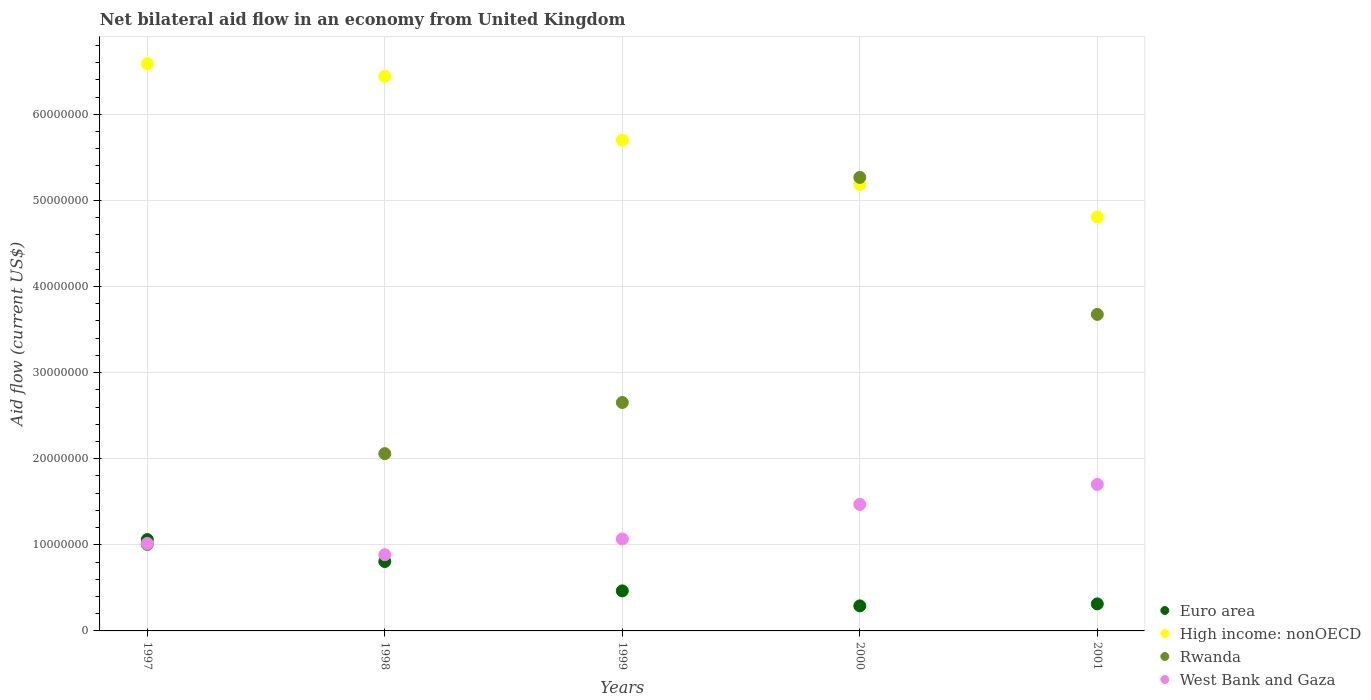Is the number of dotlines equal to the number of legend labels?
Your response must be concise. Yes. What is the net bilateral aid flow in Rwanda in 1999?
Provide a short and direct response. 2.65e+07. Across all years, what is the maximum net bilateral aid flow in Rwanda?
Your response must be concise. 5.27e+07. Across all years, what is the minimum net bilateral aid flow in Rwanda?
Your answer should be very brief. 1.00e+07. In which year was the net bilateral aid flow in High income: nonOECD maximum?
Offer a terse response. 1997. In which year was the net bilateral aid flow in High income: nonOECD minimum?
Your answer should be compact. 2001. What is the total net bilateral aid flow in High income: nonOECD in the graph?
Make the answer very short. 2.87e+08. What is the difference between the net bilateral aid flow in High income: nonOECD in 1998 and that in 2000?
Provide a succinct answer. 1.26e+07. What is the difference between the net bilateral aid flow in High income: nonOECD in 1998 and the net bilateral aid flow in Rwanda in 1999?
Offer a terse response. 3.79e+07. What is the average net bilateral aid flow in High income: nonOECD per year?
Provide a short and direct response. 5.74e+07. In the year 1998, what is the difference between the net bilateral aid flow in West Bank and Gaza and net bilateral aid flow in Euro area?
Make the answer very short. 7.90e+05. What is the ratio of the net bilateral aid flow in High income: nonOECD in 1999 to that in 2001?
Offer a terse response. 1.19. What is the difference between the highest and the second highest net bilateral aid flow in Rwanda?
Ensure brevity in your answer.  1.59e+07. What is the difference between the highest and the lowest net bilateral aid flow in Euro area?
Your answer should be very brief. 7.70e+06. In how many years, is the net bilateral aid flow in Rwanda greater than the average net bilateral aid flow in Rwanda taken over all years?
Your answer should be very brief. 2. Is it the case that in every year, the sum of the net bilateral aid flow in West Bank and Gaza and net bilateral aid flow in Rwanda  is greater than the net bilateral aid flow in Euro area?
Provide a short and direct response. Yes. Does the net bilateral aid flow in West Bank and Gaza monotonically increase over the years?
Your answer should be very brief. No. How many years are there in the graph?
Offer a terse response. 5. Where does the legend appear in the graph?
Your answer should be compact. Bottom right. What is the title of the graph?
Offer a very short reply. Net bilateral aid flow in an economy from United Kingdom. What is the Aid flow (current US$) in Euro area in 1997?
Give a very brief answer. 1.06e+07. What is the Aid flow (current US$) of High income: nonOECD in 1997?
Make the answer very short. 6.59e+07. What is the Aid flow (current US$) in Rwanda in 1997?
Provide a succinct answer. 1.00e+07. What is the Aid flow (current US$) in West Bank and Gaza in 1997?
Give a very brief answer. 1.02e+07. What is the Aid flow (current US$) of Euro area in 1998?
Keep it short and to the point. 8.06e+06. What is the Aid flow (current US$) of High income: nonOECD in 1998?
Keep it short and to the point. 6.44e+07. What is the Aid flow (current US$) in Rwanda in 1998?
Keep it short and to the point. 2.06e+07. What is the Aid flow (current US$) of West Bank and Gaza in 1998?
Your answer should be compact. 8.85e+06. What is the Aid flow (current US$) in Euro area in 1999?
Offer a terse response. 4.65e+06. What is the Aid flow (current US$) of High income: nonOECD in 1999?
Ensure brevity in your answer.  5.70e+07. What is the Aid flow (current US$) of Rwanda in 1999?
Offer a terse response. 2.65e+07. What is the Aid flow (current US$) of West Bank and Gaza in 1999?
Offer a very short reply. 1.07e+07. What is the Aid flow (current US$) of Euro area in 2000?
Provide a succinct answer. 2.91e+06. What is the Aid flow (current US$) in High income: nonOECD in 2000?
Make the answer very short. 5.18e+07. What is the Aid flow (current US$) in Rwanda in 2000?
Offer a terse response. 5.27e+07. What is the Aid flow (current US$) of West Bank and Gaza in 2000?
Your response must be concise. 1.47e+07. What is the Aid flow (current US$) of Euro area in 2001?
Ensure brevity in your answer.  3.14e+06. What is the Aid flow (current US$) in High income: nonOECD in 2001?
Your answer should be compact. 4.81e+07. What is the Aid flow (current US$) in Rwanda in 2001?
Keep it short and to the point. 3.68e+07. What is the Aid flow (current US$) of West Bank and Gaza in 2001?
Provide a succinct answer. 1.70e+07. Across all years, what is the maximum Aid flow (current US$) of Euro area?
Keep it short and to the point. 1.06e+07. Across all years, what is the maximum Aid flow (current US$) of High income: nonOECD?
Keep it short and to the point. 6.59e+07. Across all years, what is the maximum Aid flow (current US$) in Rwanda?
Provide a short and direct response. 5.27e+07. Across all years, what is the maximum Aid flow (current US$) of West Bank and Gaza?
Offer a terse response. 1.70e+07. Across all years, what is the minimum Aid flow (current US$) in Euro area?
Offer a terse response. 2.91e+06. Across all years, what is the minimum Aid flow (current US$) in High income: nonOECD?
Give a very brief answer. 4.81e+07. Across all years, what is the minimum Aid flow (current US$) in Rwanda?
Your answer should be very brief. 1.00e+07. Across all years, what is the minimum Aid flow (current US$) of West Bank and Gaza?
Ensure brevity in your answer.  8.85e+06. What is the total Aid flow (current US$) in Euro area in the graph?
Provide a short and direct response. 2.94e+07. What is the total Aid flow (current US$) in High income: nonOECD in the graph?
Offer a very short reply. 2.87e+08. What is the total Aid flow (current US$) in Rwanda in the graph?
Make the answer very short. 1.47e+08. What is the total Aid flow (current US$) of West Bank and Gaza in the graph?
Your answer should be compact. 6.14e+07. What is the difference between the Aid flow (current US$) in Euro area in 1997 and that in 1998?
Provide a short and direct response. 2.55e+06. What is the difference between the Aid flow (current US$) in High income: nonOECD in 1997 and that in 1998?
Make the answer very short. 1.47e+06. What is the difference between the Aid flow (current US$) in Rwanda in 1997 and that in 1998?
Keep it short and to the point. -1.06e+07. What is the difference between the Aid flow (current US$) of West Bank and Gaza in 1997 and that in 1998?
Give a very brief answer. 1.31e+06. What is the difference between the Aid flow (current US$) of Euro area in 1997 and that in 1999?
Make the answer very short. 5.96e+06. What is the difference between the Aid flow (current US$) in High income: nonOECD in 1997 and that in 1999?
Offer a very short reply. 8.89e+06. What is the difference between the Aid flow (current US$) of Rwanda in 1997 and that in 1999?
Provide a short and direct response. -1.65e+07. What is the difference between the Aid flow (current US$) in West Bank and Gaza in 1997 and that in 1999?
Your answer should be very brief. -5.20e+05. What is the difference between the Aid flow (current US$) in Euro area in 1997 and that in 2000?
Keep it short and to the point. 7.70e+06. What is the difference between the Aid flow (current US$) in High income: nonOECD in 1997 and that in 2000?
Your answer should be compact. 1.40e+07. What is the difference between the Aid flow (current US$) of Rwanda in 1997 and that in 2000?
Your answer should be very brief. -4.26e+07. What is the difference between the Aid flow (current US$) of West Bank and Gaza in 1997 and that in 2000?
Offer a very short reply. -4.53e+06. What is the difference between the Aid flow (current US$) in Euro area in 1997 and that in 2001?
Give a very brief answer. 7.47e+06. What is the difference between the Aid flow (current US$) of High income: nonOECD in 1997 and that in 2001?
Provide a succinct answer. 1.78e+07. What is the difference between the Aid flow (current US$) in Rwanda in 1997 and that in 2001?
Offer a terse response. -2.67e+07. What is the difference between the Aid flow (current US$) of West Bank and Gaza in 1997 and that in 2001?
Provide a succinct answer. -6.85e+06. What is the difference between the Aid flow (current US$) in Euro area in 1998 and that in 1999?
Give a very brief answer. 3.41e+06. What is the difference between the Aid flow (current US$) of High income: nonOECD in 1998 and that in 1999?
Your answer should be compact. 7.42e+06. What is the difference between the Aid flow (current US$) of Rwanda in 1998 and that in 1999?
Offer a terse response. -5.94e+06. What is the difference between the Aid flow (current US$) of West Bank and Gaza in 1998 and that in 1999?
Offer a terse response. -1.83e+06. What is the difference between the Aid flow (current US$) of Euro area in 1998 and that in 2000?
Offer a terse response. 5.15e+06. What is the difference between the Aid flow (current US$) of High income: nonOECD in 1998 and that in 2000?
Your answer should be compact. 1.26e+07. What is the difference between the Aid flow (current US$) in Rwanda in 1998 and that in 2000?
Ensure brevity in your answer.  -3.21e+07. What is the difference between the Aid flow (current US$) in West Bank and Gaza in 1998 and that in 2000?
Offer a terse response. -5.84e+06. What is the difference between the Aid flow (current US$) of Euro area in 1998 and that in 2001?
Make the answer very short. 4.92e+06. What is the difference between the Aid flow (current US$) of High income: nonOECD in 1998 and that in 2001?
Your answer should be very brief. 1.63e+07. What is the difference between the Aid flow (current US$) of Rwanda in 1998 and that in 2001?
Offer a terse response. -1.62e+07. What is the difference between the Aid flow (current US$) in West Bank and Gaza in 1998 and that in 2001?
Provide a succinct answer. -8.16e+06. What is the difference between the Aid flow (current US$) of Euro area in 1999 and that in 2000?
Offer a very short reply. 1.74e+06. What is the difference between the Aid flow (current US$) of High income: nonOECD in 1999 and that in 2000?
Your answer should be very brief. 5.15e+06. What is the difference between the Aid flow (current US$) in Rwanda in 1999 and that in 2000?
Offer a terse response. -2.61e+07. What is the difference between the Aid flow (current US$) in West Bank and Gaza in 1999 and that in 2000?
Give a very brief answer. -4.01e+06. What is the difference between the Aid flow (current US$) of Euro area in 1999 and that in 2001?
Make the answer very short. 1.51e+06. What is the difference between the Aid flow (current US$) in High income: nonOECD in 1999 and that in 2001?
Ensure brevity in your answer.  8.92e+06. What is the difference between the Aid flow (current US$) of Rwanda in 1999 and that in 2001?
Make the answer very short. -1.02e+07. What is the difference between the Aid flow (current US$) of West Bank and Gaza in 1999 and that in 2001?
Provide a succinct answer. -6.33e+06. What is the difference between the Aid flow (current US$) in Euro area in 2000 and that in 2001?
Provide a short and direct response. -2.30e+05. What is the difference between the Aid flow (current US$) of High income: nonOECD in 2000 and that in 2001?
Your response must be concise. 3.77e+06. What is the difference between the Aid flow (current US$) of Rwanda in 2000 and that in 2001?
Keep it short and to the point. 1.59e+07. What is the difference between the Aid flow (current US$) of West Bank and Gaza in 2000 and that in 2001?
Your answer should be compact. -2.32e+06. What is the difference between the Aid flow (current US$) in Euro area in 1997 and the Aid flow (current US$) in High income: nonOECD in 1998?
Keep it short and to the point. -5.38e+07. What is the difference between the Aid flow (current US$) in Euro area in 1997 and the Aid flow (current US$) in Rwanda in 1998?
Give a very brief answer. -9.98e+06. What is the difference between the Aid flow (current US$) of Euro area in 1997 and the Aid flow (current US$) of West Bank and Gaza in 1998?
Give a very brief answer. 1.76e+06. What is the difference between the Aid flow (current US$) of High income: nonOECD in 1997 and the Aid flow (current US$) of Rwanda in 1998?
Your response must be concise. 4.53e+07. What is the difference between the Aid flow (current US$) of High income: nonOECD in 1997 and the Aid flow (current US$) of West Bank and Gaza in 1998?
Provide a short and direct response. 5.70e+07. What is the difference between the Aid flow (current US$) of Rwanda in 1997 and the Aid flow (current US$) of West Bank and Gaza in 1998?
Ensure brevity in your answer.  1.19e+06. What is the difference between the Aid flow (current US$) of Euro area in 1997 and the Aid flow (current US$) of High income: nonOECD in 1999?
Your answer should be very brief. -4.64e+07. What is the difference between the Aid flow (current US$) in Euro area in 1997 and the Aid flow (current US$) in Rwanda in 1999?
Make the answer very short. -1.59e+07. What is the difference between the Aid flow (current US$) of Euro area in 1997 and the Aid flow (current US$) of West Bank and Gaza in 1999?
Provide a succinct answer. -7.00e+04. What is the difference between the Aid flow (current US$) of High income: nonOECD in 1997 and the Aid flow (current US$) of Rwanda in 1999?
Offer a terse response. 3.94e+07. What is the difference between the Aid flow (current US$) in High income: nonOECD in 1997 and the Aid flow (current US$) in West Bank and Gaza in 1999?
Your answer should be compact. 5.52e+07. What is the difference between the Aid flow (current US$) in Rwanda in 1997 and the Aid flow (current US$) in West Bank and Gaza in 1999?
Offer a terse response. -6.40e+05. What is the difference between the Aid flow (current US$) of Euro area in 1997 and the Aid flow (current US$) of High income: nonOECD in 2000?
Your response must be concise. -4.12e+07. What is the difference between the Aid flow (current US$) in Euro area in 1997 and the Aid flow (current US$) in Rwanda in 2000?
Offer a terse response. -4.21e+07. What is the difference between the Aid flow (current US$) of Euro area in 1997 and the Aid flow (current US$) of West Bank and Gaza in 2000?
Make the answer very short. -4.08e+06. What is the difference between the Aid flow (current US$) of High income: nonOECD in 1997 and the Aid flow (current US$) of Rwanda in 2000?
Ensure brevity in your answer.  1.32e+07. What is the difference between the Aid flow (current US$) in High income: nonOECD in 1997 and the Aid flow (current US$) in West Bank and Gaza in 2000?
Make the answer very short. 5.12e+07. What is the difference between the Aid flow (current US$) of Rwanda in 1997 and the Aid flow (current US$) of West Bank and Gaza in 2000?
Your response must be concise. -4.65e+06. What is the difference between the Aid flow (current US$) in Euro area in 1997 and the Aid flow (current US$) in High income: nonOECD in 2001?
Your answer should be compact. -3.75e+07. What is the difference between the Aid flow (current US$) of Euro area in 1997 and the Aid flow (current US$) of Rwanda in 2001?
Keep it short and to the point. -2.62e+07. What is the difference between the Aid flow (current US$) of Euro area in 1997 and the Aid flow (current US$) of West Bank and Gaza in 2001?
Your answer should be compact. -6.40e+06. What is the difference between the Aid flow (current US$) in High income: nonOECD in 1997 and the Aid flow (current US$) in Rwanda in 2001?
Provide a short and direct response. 2.91e+07. What is the difference between the Aid flow (current US$) in High income: nonOECD in 1997 and the Aid flow (current US$) in West Bank and Gaza in 2001?
Provide a succinct answer. 4.89e+07. What is the difference between the Aid flow (current US$) of Rwanda in 1997 and the Aid flow (current US$) of West Bank and Gaza in 2001?
Keep it short and to the point. -6.97e+06. What is the difference between the Aid flow (current US$) of Euro area in 1998 and the Aid flow (current US$) of High income: nonOECD in 1999?
Ensure brevity in your answer.  -4.89e+07. What is the difference between the Aid flow (current US$) in Euro area in 1998 and the Aid flow (current US$) in Rwanda in 1999?
Keep it short and to the point. -1.85e+07. What is the difference between the Aid flow (current US$) of Euro area in 1998 and the Aid flow (current US$) of West Bank and Gaza in 1999?
Offer a terse response. -2.62e+06. What is the difference between the Aid flow (current US$) in High income: nonOECD in 1998 and the Aid flow (current US$) in Rwanda in 1999?
Offer a terse response. 3.79e+07. What is the difference between the Aid flow (current US$) of High income: nonOECD in 1998 and the Aid flow (current US$) of West Bank and Gaza in 1999?
Provide a succinct answer. 5.37e+07. What is the difference between the Aid flow (current US$) in Rwanda in 1998 and the Aid flow (current US$) in West Bank and Gaza in 1999?
Keep it short and to the point. 9.91e+06. What is the difference between the Aid flow (current US$) of Euro area in 1998 and the Aid flow (current US$) of High income: nonOECD in 2000?
Provide a short and direct response. -4.38e+07. What is the difference between the Aid flow (current US$) in Euro area in 1998 and the Aid flow (current US$) in Rwanda in 2000?
Ensure brevity in your answer.  -4.46e+07. What is the difference between the Aid flow (current US$) in Euro area in 1998 and the Aid flow (current US$) in West Bank and Gaza in 2000?
Give a very brief answer. -6.63e+06. What is the difference between the Aid flow (current US$) of High income: nonOECD in 1998 and the Aid flow (current US$) of Rwanda in 2000?
Provide a succinct answer. 1.17e+07. What is the difference between the Aid flow (current US$) of High income: nonOECD in 1998 and the Aid flow (current US$) of West Bank and Gaza in 2000?
Give a very brief answer. 4.97e+07. What is the difference between the Aid flow (current US$) in Rwanda in 1998 and the Aid flow (current US$) in West Bank and Gaza in 2000?
Offer a very short reply. 5.90e+06. What is the difference between the Aid flow (current US$) in Euro area in 1998 and the Aid flow (current US$) in High income: nonOECD in 2001?
Your response must be concise. -4.00e+07. What is the difference between the Aid flow (current US$) of Euro area in 1998 and the Aid flow (current US$) of Rwanda in 2001?
Your answer should be compact. -2.87e+07. What is the difference between the Aid flow (current US$) in Euro area in 1998 and the Aid flow (current US$) in West Bank and Gaza in 2001?
Your response must be concise. -8.95e+06. What is the difference between the Aid flow (current US$) in High income: nonOECD in 1998 and the Aid flow (current US$) in Rwanda in 2001?
Provide a short and direct response. 2.76e+07. What is the difference between the Aid flow (current US$) of High income: nonOECD in 1998 and the Aid flow (current US$) of West Bank and Gaza in 2001?
Provide a short and direct response. 4.74e+07. What is the difference between the Aid flow (current US$) in Rwanda in 1998 and the Aid flow (current US$) in West Bank and Gaza in 2001?
Give a very brief answer. 3.58e+06. What is the difference between the Aid flow (current US$) of Euro area in 1999 and the Aid flow (current US$) of High income: nonOECD in 2000?
Your response must be concise. -4.72e+07. What is the difference between the Aid flow (current US$) of Euro area in 1999 and the Aid flow (current US$) of Rwanda in 2000?
Your answer should be compact. -4.80e+07. What is the difference between the Aid flow (current US$) in Euro area in 1999 and the Aid flow (current US$) in West Bank and Gaza in 2000?
Offer a terse response. -1.00e+07. What is the difference between the Aid flow (current US$) in High income: nonOECD in 1999 and the Aid flow (current US$) in Rwanda in 2000?
Keep it short and to the point. 4.32e+06. What is the difference between the Aid flow (current US$) of High income: nonOECD in 1999 and the Aid flow (current US$) of West Bank and Gaza in 2000?
Provide a succinct answer. 4.23e+07. What is the difference between the Aid flow (current US$) in Rwanda in 1999 and the Aid flow (current US$) in West Bank and Gaza in 2000?
Make the answer very short. 1.18e+07. What is the difference between the Aid flow (current US$) of Euro area in 1999 and the Aid flow (current US$) of High income: nonOECD in 2001?
Keep it short and to the point. -4.34e+07. What is the difference between the Aid flow (current US$) of Euro area in 1999 and the Aid flow (current US$) of Rwanda in 2001?
Your answer should be compact. -3.21e+07. What is the difference between the Aid flow (current US$) in Euro area in 1999 and the Aid flow (current US$) in West Bank and Gaza in 2001?
Provide a short and direct response. -1.24e+07. What is the difference between the Aid flow (current US$) of High income: nonOECD in 1999 and the Aid flow (current US$) of Rwanda in 2001?
Provide a succinct answer. 2.02e+07. What is the difference between the Aid flow (current US$) in High income: nonOECD in 1999 and the Aid flow (current US$) in West Bank and Gaza in 2001?
Your answer should be compact. 4.00e+07. What is the difference between the Aid flow (current US$) of Rwanda in 1999 and the Aid flow (current US$) of West Bank and Gaza in 2001?
Make the answer very short. 9.52e+06. What is the difference between the Aid flow (current US$) in Euro area in 2000 and the Aid flow (current US$) in High income: nonOECD in 2001?
Give a very brief answer. -4.52e+07. What is the difference between the Aid flow (current US$) in Euro area in 2000 and the Aid flow (current US$) in Rwanda in 2001?
Provide a short and direct response. -3.38e+07. What is the difference between the Aid flow (current US$) of Euro area in 2000 and the Aid flow (current US$) of West Bank and Gaza in 2001?
Your response must be concise. -1.41e+07. What is the difference between the Aid flow (current US$) in High income: nonOECD in 2000 and the Aid flow (current US$) in Rwanda in 2001?
Give a very brief answer. 1.51e+07. What is the difference between the Aid flow (current US$) of High income: nonOECD in 2000 and the Aid flow (current US$) of West Bank and Gaza in 2001?
Offer a terse response. 3.48e+07. What is the difference between the Aid flow (current US$) in Rwanda in 2000 and the Aid flow (current US$) in West Bank and Gaza in 2001?
Your answer should be very brief. 3.57e+07. What is the average Aid flow (current US$) of Euro area per year?
Ensure brevity in your answer.  5.87e+06. What is the average Aid flow (current US$) of High income: nonOECD per year?
Make the answer very short. 5.74e+07. What is the average Aid flow (current US$) of Rwanda per year?
Offer a very short reply. 2.93e+07. What is the average Aid flow (current US$) of West Bank and Gaza per year?
Offer a terse response. 1.23e+07. In the year 1997, what is the difference between the Aid flow (current US$) in Euro area and Aid flow (current US$) in High income: nonOECD?
Provide a short and direct response. -5.53e+07. In the year 1997, what is the difference between the Aid flow (current US$) in Euro area and Aid flow (current US$) in Rwanda?
Your response must be concise. 5.70e+05. In the year 1997, what is the difference between the Aid flow (current US$) in High income: nonOECD and Aid flow (current US$) in Rwanda?
Offer a terse response. 5.58e+07. In the year 1997, what is the difference between the Aid flow (current US$) in High income: nonOECD and Aid flow (current US$) in West Bank and Gaza?
Your answer should be very brief. 5.57e+07. In the year 1998, what is the difference between the Aid flow (current US$) of Euro area and Aid flow (current US$) of High income: nonOECD?
Keep it short and to the point. -5.64e+07. In the year 1998, what is the difference between the Aid flow (current US$) in Euro area and Aid flow (current US$) in Rwanda?
Ensure brevity in your answer.  -1.25e+07. In the year 1998, what is the difference between the Aid flow (current US$) in Euro area and Aid flow (current US$) in West Bank and Gaza?
Ensure brevity in your answer.  -7.90e+05. In the year 1998, what is the difference between the Aid flow (current US$) in High income: nonOECD and Aid flow (current US$) in Rwanda?
Provide a short and direct response. 4.38e+07. In the year 1998, what is the difference between the Aid flow (current US$) of High income: nonOECD and Aid flow (current US$) of West Bank and Gaza?
Keep it short and to the point. 5.56e+07. In the year 1998, what is the difference between the Aid flow (current US$) of Rwanda and Aid flow (current US$) of West Bank and Gaza?
Your answer should be very brief. 1.17e+07. In the year 1999, what is the difference between the Aid flow (current US$) in Euro area and Aid flow (current US$) in High income: nonOECD?
Give a very brief answer. -5.23e+07. In the year 1999, what is the difference between the Aid flow (current US$) in Euro area and Aid flow (current US$) in Rwanda?
Provide a short and direct response. -2.19e+07. In the year 1999, what is the difference between the Aid flow (current US$) of Euro area and Aid flow (current US$) of West Bank and Gaza?
Provide a succinct answer. -6.03e+06. In the year 1999, what is the difference between the Aid flow (current US$) in High income: nonOECD and Aid flow (current US$) in Rwanda?
Your answer should be compact. 3.05e+07. In the year 1999, what is the difference between the Aid flow (current US$) in High income: nonOECD and Aid flow (current US$) in West Bank and Gaza?
Offer a terse response. 4.63e+07. In the year 1999, what is the difference between the Aid flow (current US$) of Rwanda and Aid flow (current US$) of West Bank and Gaza?
Your answer should be very brief. 1.58e+07. In the year 2000, what is the difference between the Aid flow (current US$) in Euro area and Aid flow (current US$) in High income: nonOECD?
Keep it short and to the point. -4.89e+07. In the year 2000, what is the difference between the Aid flow (current US$) of Euro area and Aid flow (current US$) of Rwanda?
Make the answer very short. -4.98e+07. In the year 2000, what is the difference between the Aid flow (current US$) of Euro area and Aid flow (current US$) of West Bank and Gaza?
Your answer should be very brief. -1.18e+07. In the year 2000, what is the difference between the Aid flow (current US$) in High income: nonOECD and Aid flow (current US$) in Rwanda?
Provide a short and direct response. -8.30e+05. In the year 2000, what is the difference between the Aid flow (current US$) in High income: nonOECD and Aid flow (current US$) in West Bank and Gaza?
Keep it short and to the point. 3.72e+07. In the year 2000, what is the difference between the Aid flow (current US$) in Rwanda and Aid flow (current US$) in West Bank and Gaza?
Provide a short and direct response. 3.80e+07. In the year 2001, what is the difference between the Aid flow (current US$) of Euro area and Aid flow (current US$) of High income: nonOECD?
Your response must be concise. -4.49e+07. In the year 2001, what is the difference between the Aid flow (current US$) of Euro area and Aid flow (current US$) of Rwanda?
Ensure brevity in your answer.  -3.36e+07. In the year 2001, what is the difference between the Aid flow (current US$) of Euro area and Aid flow (current US$) of West Bank and Gaza?
Give a very brief answer. -1.39e+07. In the year 2001, what is the difference between the Aid flow (current US$) in High income: nonOECD and Aid flow (current US$) in Rwanda?
Offer a very short reply. 1.13e+07. In the year 2001, what is the difference between the Aid flow (current US$) of High income: nonOECD and Aid flow (current US$) of West Bank and Gaza?
Provide a succinct answer. 3.11e+07. In the year 2001, what is the difference between the Aid flow (current US$) in Rwanda and Aid flow (current US$) in West Bank and Gaza?
Provide a succinct answer. 1.98e+07. What is the ratio of the Aid flow (current US$) in Euro area in 1997 to that in 1998?
Keep it short and to the point. 1.32. What is the ratio of the Aid flow (current US$) in High income: nonOECD in 1997 to that in 1998?
Ensure brevity in your answer.  1.02. What is the ratio of the Aid flow (current US$) in Rwanda in 1997 to that in 1998?
Your response must be concise. 0.49. What is the ratio of the Aid flow (current US$) of West Bank and Gaza in 1997 to that in 1998?
Ensure brevity in your answer.  1.15. What is the ratio of the Aid flow (current US$) in Euro area in 1997 to that in 1999?
Provide a short and direct response. 2.28. What is the ratio of the Aid flow (current US$) in High income: nonOECD in 1997 to that in 1999?
Ensure brevity in your answer.  1.16. What is the ratio of the Aid flow (current US$) in Rwanda in 1997 to that in 1999?
Provide a short and direct response. 0.38. What is the ratio of the Aid flow (current US$) of West Bank and Gaza in 1997 to that in 1999?
Your answer should be compact. 0.95. What is the ratio of the Aid flow (current US$) in Euro area in 1997 to that in 2000?
Your answer should be compact. 3.65. What is the ratio of the Aid flow (current US$) in High income: nonOECD in 1997 to that in 2000?
Your answer should be very brief. 1.27. What is the ratio of the Aid flow (current US$) of Rwanda in 1997 to that in 2000?
Provide a short and direct response. 0.19. What is the ratio of the Aid flow (current US$) of West Bank and Gaza in 1997 to that in 2000?
Your answer should be compact. 0.69. What is the ratio of the Aid flow (current US$) of Euro area in 1997 to that in 2001?
Provide a succinct answer. 3.38. What is the ratio of the Aid flow (current US$) in High income: nonOECD in 1997 to that in 2001?
Make the answer very short. 1.37. What is the ratio of the Aid flow (current US$) in Rwanda in 1997 to that in 2001?
Offer a very short reply. 0.27. What is the ratio of the Aid flow (current US$) in West Bank and Gaza in 1997 to that in 2001?
Offer a very short reply. 0.6. What is the ratio of the Aid flow (current US$) of Euro area in 1998 to that in 1999?
Keep it short and to the point. 1.73. What is the ratio of the Aid flow (current US$) in High income: nonOECD in 1998 to that in 1999?
Offer a terse response. 1.13. What is the ratio of the Aid flow (current US$) of Rwanda in 1998 to that in 1999?
Your answer should be very brief. 0.78. What is the ratio of the Aid flow (current US$) of West Bank and Gaza in 1998 to that in 1999?
Your answer should be very brief. 0.83. What is the ratio of the Aid flow (current US$) of Euro area in 1998 to that in 2000?
Make the answer very short. 2.77. What is the ratio of the Aid flow (current US$) of High income: nonOECD in 1998 to that in 2000?
Your response must be concise. 1.24. What is the ratio of the Aid flow (current US$) in Rwanda in 1998 to that in 2000?
Your response must be concise. 0.39. What is the ratio of the Aid flow (current US$) in West Bank and Gaza in 1998 to that in 2000?
Your answer should be compact. 0.6. What is the ratio of the Aid flow (current US$) in Euro area in 1998 to that in 2001?
Ensure brevity in your answer.  2.57. What is the ratio of the Aid flow (current US$) of High income: nonOECD in 1998 to that in 2001?
Provide a succinct answer. 1.34. What is the ratio of the Aid flow (current US$) of Rwanda in 1998 to that in 2001?
Provide a succinct answer. 0.56. What is the ratio of the Aid flow (current US$) of West Bank and Gaza in 1998 to that in 2001?
Make the answer very short. 0.52. What is the ratio of the Aid flow (current US$) of Euro area in 1999 to that in 2000?
Give a very brief answer. 1.6. What is the ratio of the Aid flow (current US$) of High income: nonOECD in 1999 to that in 2000?
Provide a short and direct response. 1.1. What is the ratio of the Aid flow (current US$) in Rwanda in 1999 to that in 2000?
Your response must be concise. 0.5. What is the ratio of the Aid flow (current US$) of West Bank and Gaza in 1999 to that in 2000?
Your response must be concise. 0.73. What is the ratio of the Aid flow (current US$) of Euro area in 1999 to that in 2001?
Your answer should be compact. 1.48. What is the ratio of the Aid flow (current US$) of High income: nonOECD in 1999 to that in 2001?
Your answer should be very brief. 1.19. What is the ratio of the Aid flow (current US$) in Rwanda in 1999 to that in 2001?
Offer a very short reply. 0.72. What is the ratio of the Aid flow (current US$) in West Bank and Gaza in 1999 to that in 2001?
Ensure brevity in your answer.  0.63. What is the ratio of the Aid flow (current US$) in Euro area in 2000 to that in 2001?
Offer a very short reply. 0.93. What is the ratio of the Aid flow (current US$) in High income: nonOECD in 2000 to that in 2001?
Offer a very short reply. 1.08. What is the ratio of the Aid flow (current US$) in Rwanda in 2000 to that in 2001?
Offer a terse response. 1.43. What is the ratio of the Aid flow (current US$) in West Bank and Gaza in 2000 to that in 2001?
Your response must be concise. 0.86. What is the difference between the highest and the second highest Aid flow (current US$) of Euro area?
Your answer should be very brief. 2.55e+06. What is the difference between the highest and the second highest Aid flow (current US$) of High income: nonOECD?
Give a very brief answer. 1.47e+06. What is the difference between the highest and the second highest Aid flow (current US$) of Rwanda?
Your response must be concise. 1.59e+07. What is the difference between the highest and the second highest Aid flow (current US$) of West Bank and Gaza?
Give a very brief answer. 2.32e+06. What is the difference between the highest and the lowest Aid flow (current US$) of Euro area?
Provide a short and direct response. 7.70e+06. What is the difference between the highest and the lowest Aid flow (current US$) of High income: nonOECD?
Your response must be concise. 1.78e+07. What is the difference between the highest and the lowest Aid flow (current US$) in Rwanda?
Make the answer very short. 4.26e+07. What is the difference between the highest and the lowest Aid flow (current US$) of West Bank and Gaza?
Your answer should be compact. 8.16e+06. 